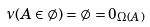<formula> <loc_0><loc_0><loc_500><loc_500>\nu ( A \in \emptyset ) = \emptyset = 0 _ { { \Omega } ( A ) }</formula> 